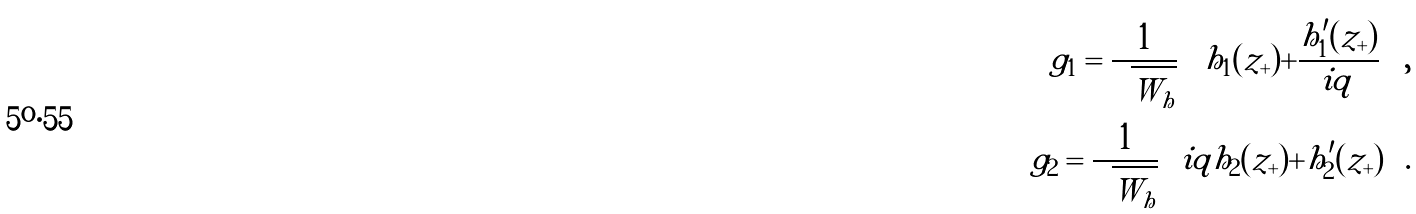<formula> <loc_0><loc_0><loc_500><loc_500>g _ { 1 } = \frac { 1 } { \sqrt { W _ { h } } } \left [ h _ { 1 } ( z _ { + } ) + \frac { h _ { 1 } ^ { \prime } ( z _ { + } ) } { i q } \right ] , \\ g _ { 2 } = \frac { 1 } { \sqrt { W _ { h } } } \left [ i q h _ { 2 } ( z _ { + } ) + h _ { 2 } ^ { \prime } ( z _ { + } ) \right ] .</formula> 